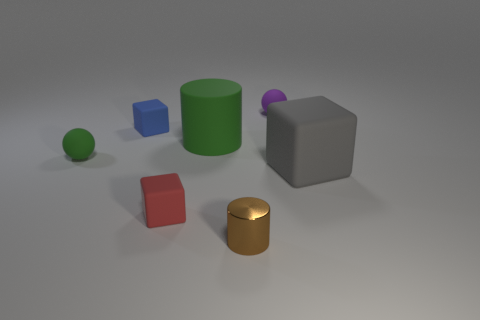Add 2 tiny blue rubber cubes. How many objects exist? 9 Subtract all blocks. How many objects are left? 4 Subtract 0 red spheres. How many objects are left? 7 Subtract all red shiny spheres. Subtract all metallic objects. How many objects are left? 6 Add 1 small green balls. How many small green balls are left? 2 Add 6 small green objects. How many small green objects exist? 7 